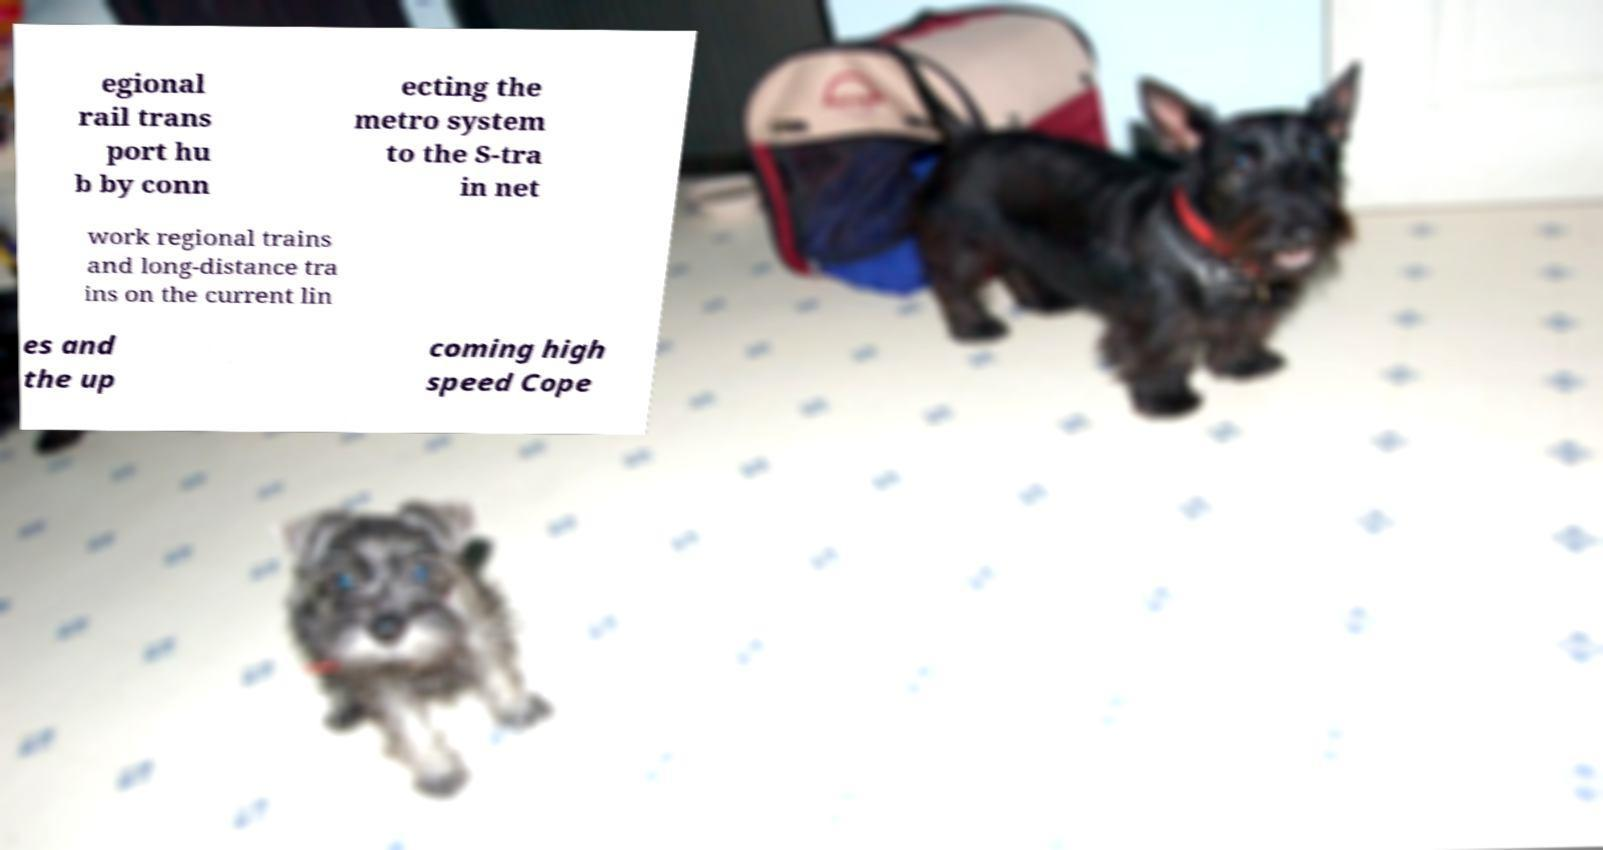Please identify and transcribe the text found in this image. egional rail trans port hu b by conn ecting the metro system to the S-tra in net work regional trains and long-distance tra ins on the current lin es and the up coming high speed Cope 